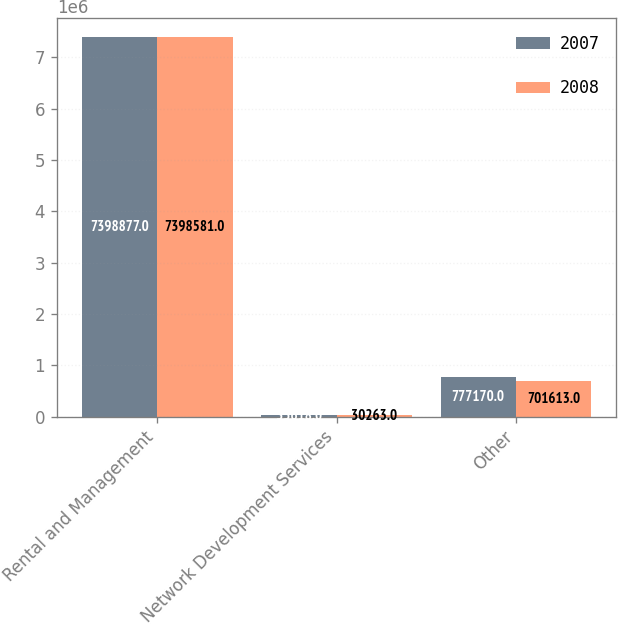<chart> <loc_0><loc_0><loc_500><loc_500><stacked_bar_chart><ecel><fcel>Rental and Management<fcel>Network Development Services<fcel>Other<nl><fcel>2007<fcel>7.39888e+06<fcel>35618<fcel>777170<nl><fcel>2008<fcel>7.39858e+06<fcel>30263<fcel>701613<nl></chart> 